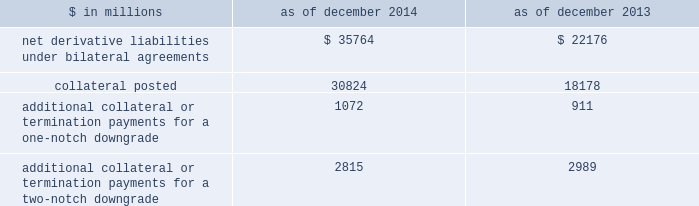Notes to consolidated financial statements derivatives with credit-related contingent features certain of the firm 2019s derivatives have been transacted under bilateral agreements with counterparties who may require the firm to post collateral or terminate the transactions based on changes in the firm 2019s credit ratings .
The firm assesses the impact of these bilateral agreements by determining the collateral or termination payments that would occur assuming a downgrade by all rating agencies .
A downgrade by any one rating agency , depending on the agency 2019s relative ratings of the firm at the time of the downgrade , may have an impact which is comparable to the impact of a downgrade by all rating agencies .
The table below presents the aggregate fair value of net derivative liabilities under such agreements ( excluding application of collateral posted to reduce these liabilities ) , the related aggregate fair value of the assets posted as collateral , and the additional collateral or termination payments that could have been called at the reporting date by counterparties in the event of a one-notch and two-notch downgrade in the firm 2019s credit ratings. .
Additional collateral or termination payments for a one-notch downgrade 1072 911 additional collateral or termination payments for a two-notch downgrade 2815 2989 credit derivatives the firm enters into a broad array of credit derivatives in locations around the world to facilitate client transactions and to manage the credit risk associated with market- making and investing and lending activities .
Credit derivatives are actively managed based on the firm 2019s net risk position .
Credit derivatives are individually negotiated contracts and can have various settlement and payment conventions .
Credit events include failure to pay , bankruptcy , acceleration of indebtedness , restructuring , repudiation and dissolution of the reference entity .
Credit default swaps .
Single-name credit default swaps protect the buyer against the loss of principal on one or more bonds , loans or mortgages ( reference obligations ) in the event the issuer ( reference entity ) of the reference obligations suffers a credit event .
The buyer of protection pays an initial or periodic premium to the seller and receives protection for the period of the contract .
If there is no credit event , as defined in the contract , the seller of protection makes no payments to the buyer of protection .
However , if a credit event occurs , the seller of protection is required to make a payment to the buyer of protection , which is calculated in accordance with the terms of the contract .
Credit indices , baskets and tranches .
Credit derivatives may reference a basket of single-name credit default swaps or a broad-based index .
If a credit event occurs in one of the underlying reference obligations , the protection seller pays the protection buyer .
The payment is typically a pro-rata portion of the transaction 2019s total notional amount based on the underlying defaulted reference obligation .
In certain transactions , the credit risk of a basket or index is separated into various portions ( tranches ) , each having different levels of subordination .
The most junior tranches cover initial defaults and once losses exceed the notional amount of these junior tranches , any excess loss is covered by the next most senior tranche in the capital structure .
Total return swaps .
A total return swap transfers the risks relating to economic performance of a reference obligation from the protection buyer to the protection seller .
Typically , the protection buyer receives from the protection seller a floating rate of interest and protection against any reduction in fair value of the reference obligation , and in return the protection seller receives the cash flows associated with the reference obligation , plus any increase in the fair value of the reference obligation .
132 goldman sachs 2014 annual report .
What was the percentage change in net derivative liabilities under bilateral agreements between 2013 and 2014? 
Computations: ((35764 - 22176) / 22176)
Answer: 0.61273. 